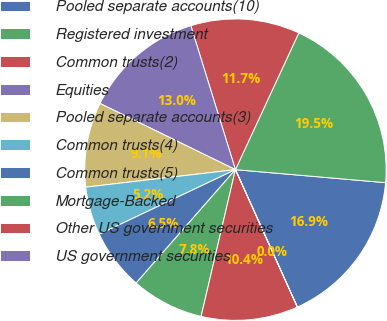Convert chart to OTSL. <chart><loc_0><loc_0><loc_500><loc_500><pie_chart><fcel>Pooled separate accounts(10)<fcel>Registered investment<fcel>Common trusts(2)<fcel>Equities<fcel>Pooled separate accounts(3)<fcel>Common trusts(4)<fcel>Common trusts(5)<fcel>Mortgage-Backed<fcel>Other US government securities<fcel>US government securities<nl><fcel>16.88%<fcel>19.47%<fcel>11.69%<fcel>12.98%<fcel>9.09%<fcel>5.2%<fcel>6.5%<fcel>7.79%<fcel>10.39%<fcel>0.01%<nl></chart> 